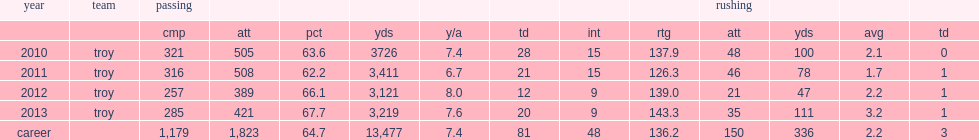How many passing yards did corey robinson have in 2010? 3726. 